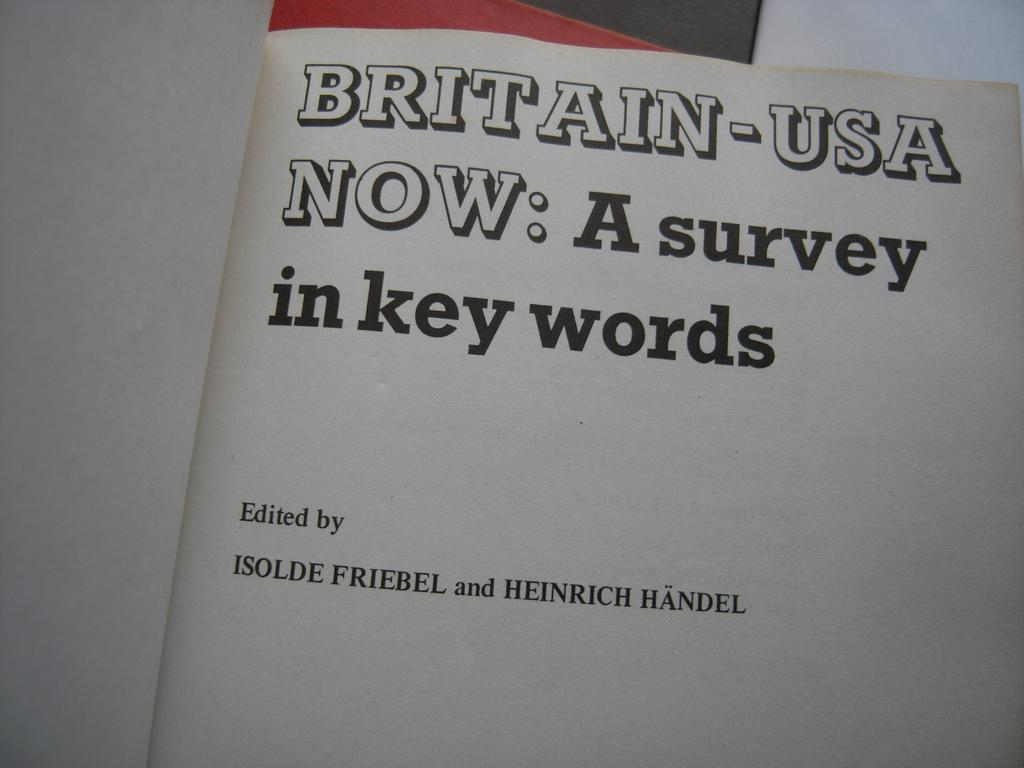<image>
Create a compact narrative representing the image presented. A book is opened and the title Britain-USA Now is written in black, block text. 